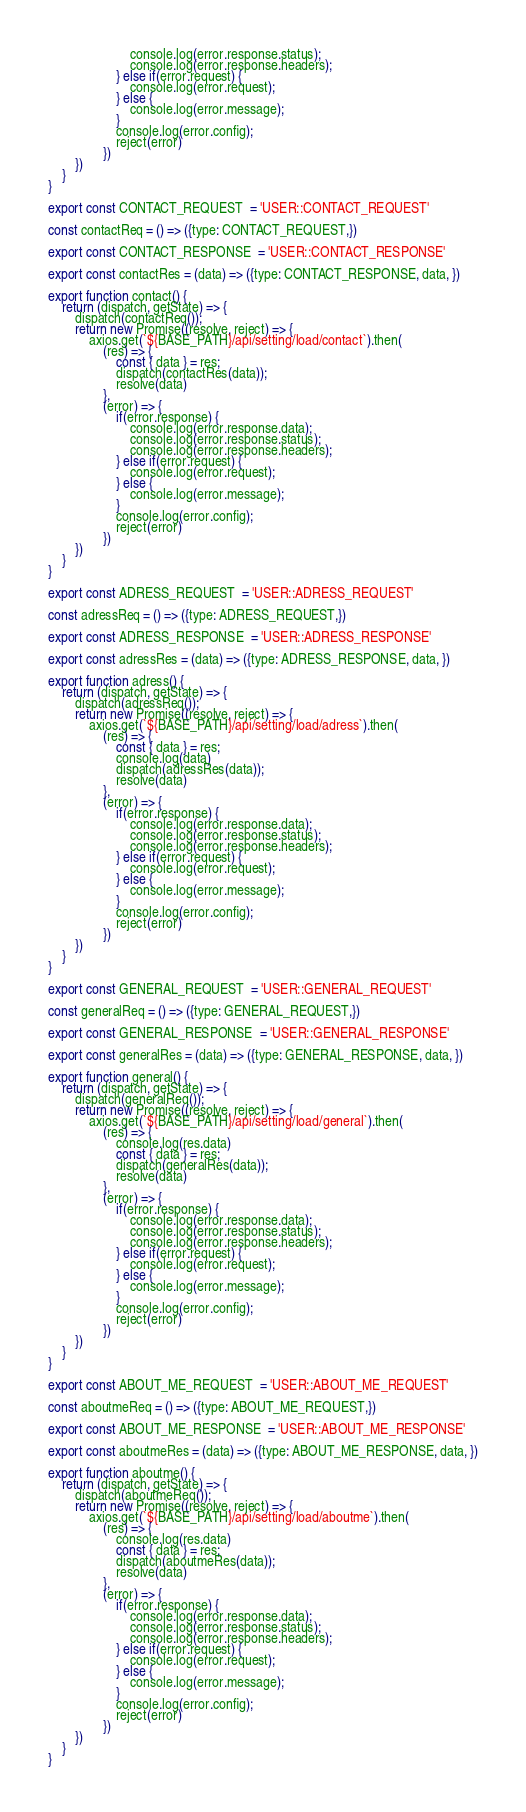<code> <loc_0><loc_0><loc_500><loc_500><_JavaScript_>                        console.log(error.response.status);
                        console.log(error.response.headers);                
                    } else if(error.request) {
                        console.log(error.request);
                    } else {
                        console.log(error.message);
                    }
                    console.log(error.config);
                    reject(error)
                })
        })
    }
}

export const CONTACT_REQUEST  = 'USER::CONTACT_REQUEST'

const contactReq = () => ({type: CONTACT_REQUEST,})

export const CONTACT_RESPONSE  = 'USER::CONTACT_RESPONSE'

export const contactRes = (data) => ({type: CONTACT_RESPONSE, data, })

export function contact() {
    return (dispatch, getState) => {
        dispatch(contactReq());
        return new Promise((resolve, reject) => {
            axios.get(`${BASE_PATH}/api/setting/load/contact`).then(
                (res) => {
                    const { data } = res;
                    dispatch(contactRes(data));
                    resolve(data)
                },
                (error) => {
                    if(error.response) {
                        console.log(error.response.data);   
                        console.log(error.response.status);
                        console.log(error.response.headers);                
                    } else if(error.request) {
                        console.log(error.request);
                    } else {
                        console.log(error.message);
                    }
                    console.log(error.config);
                    reject(error)
                })
        })
    }
}

export const ADRESS_REQUEST  = 'USER::ADRESS_REQUEST'

const adressReq = () => ({type: ADRESS_REQUEST,})

export const ADRESS_RESPONSE  = 'USER::ADRESS_RESPONSE'

export const adressRes = (data) => ({type: ADRESS_RESPONSE, data, })

export function adress() {
    return (dispatch, getState) => {
        dispatch(adressReq());
        return new Promise((resolve, reject) => {
            axios.get(`${BASE_PATH}/api/setting/load/adress`).then(
                (res) => {
                    const { data } = res;
                    console.log(data)
                    dispatch(adressRes(data));
                    resolve(data)
                },
                (error) => {
                    if(error.response) {
                        console.log(error.response.data);   
                        console.log(error.response.status);
                        console.log(error.response.headers);                
                    } else if(error.request) {
                        console.log(error.request);
                    } else {
                        console.log(error.message);
                    }
                    console.log(error.config);
                    reject(error)
                })
        })
    }
}

export const GENERAL_REQUEST  = 'USER::GENERAL_REQUEST'

const generalReq = () => ({type: GENERAL_REQUEST,})

export const GENERAL_RESPONSE  = 'USER::GENERAL_RESPONSE'

export const generalRes = (data) => ({type: GENERAL_RESPONSE, data, })

export function general() {
    return (dispatch, getState) => {
        dispatch(generalReq());
        return new Promise((resolve, reject) => {
            axios.get(`${BASE_PATH}/api/setting/load/general`).then(
                (res) => {
                    console.log(res.data)
                    const { data } = res;
                    dispatch(generalRes(data));
                    resolve(data)
                },
                (error) => {
                    if(error.response) {
                        console.log(error.response.data);   
                        console.log(error.response.status);
                        console.log(error.response.headers);                
                    } else if(error.request) {
                        console.log(error.request);
                    } else {
                        console.log(error.message);
                    }
                    console.log(error.config);
                    reject(error)
                })
        })
    }
}

export const ABOUT_ME_REQUEST  = 'USER::ABOUT_ME_REQUEST'

const aboutmeReq = () => ({type: ABOUT_ME_REQUEST,})

export const ABOUT_ME_RESPONSE  = 'USER::ABOUT_ME_RESPONSE'

export const aboutmeRes = (data) => ({type: ABOUT_ME_RESPONSE, data, })

export function aboutme() {
    return (dispatch, getState) => {
        dispatch(aboutmeReq());
        return new Promise((resolve, reject) => {
            axios.get(`${BASE_PATH}/api/setting/load/aboutme`).then(
                (res) => {
                    console.log(res.data)
                    const { data } = res;
                    dispatch(aboutmeRes(data));
                    resolve(data)
                },
                (error) => {
                    if(error.response) {
                        console.log(error.response.data);   
                        console.log(error.response.status);
                        console.log(error.response.headers);                
                    } else if(error.request) {
                        console.log(error.request);
                    } else {
                        console.log(error.message);
                    }
                    console.log(error.config);
                    reject(error)
                })
        })
    }
}</code> 